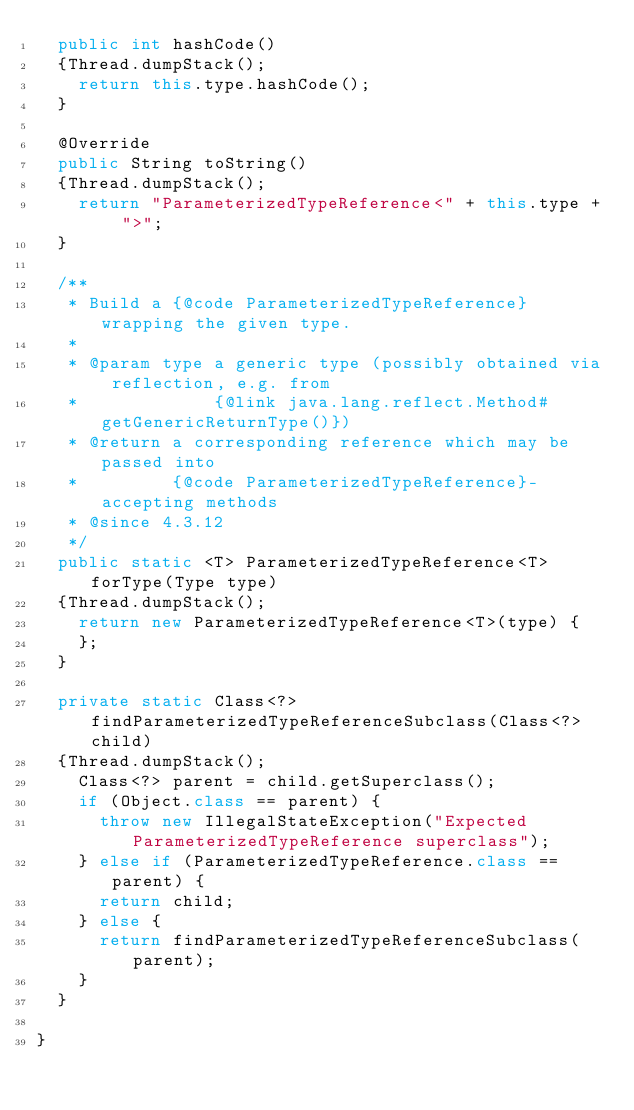<code> <loc_0><loc_0><loc_500><loc_500><_Java_>	public int hashCode()
	{Thread.dumpStack();
		return this.type.hashCode();
	}

	@Override
	public String toString()
	{Thread.dumpStack();
		return "ParameterizedTypeReference<" + this.type + ">";
	}

	/**
	 * Build a {@code ParameterizedTypeReference} wrapping the given type.
	 * 
	 * @param type a generic type (possibly obtained via reflection, e.g. from
	 *             {@link java.lang.reflect.Method#getGenericReturnType()})
	 * @return a corresponding reference which may be passed into
	 *         {@code ParameterizedTypeReference}-accepting methods
	 * @since 4.3.12
	 */
	public static <T> ParameterizedTypeReference<T> forType(Type type)
	{Thread.dumpStack();
		return new ParameterizedTypeReference<T>(type) {
		};
	}

	private static Class<?> findParameterizedTypeReferenceSubclass(Class<?> child)
	{Thread.dumpStack();
		Class<?> parent = child.getSuperclass();
		if (Object.class == parent) {
			throw new IllegalStateException("Expected ParameterizedTypeReference superclass");
		} else if (ParameterizedTypeReference.class == parent) {
			return child;
		} else {
			return findParameterizedTypeReferenceSubclass(parent);
		}
	}

}
</code> 